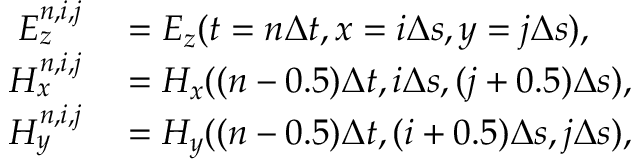Convert formula to latex. <formula><loc_0><loc_0><loc_500><loc_500>\begin{array} { r l } { E _ { z } ^ { n , i , j } } & = E _ { z } ( t = n \Delta t , x = i \Delta s , y = j \Delta s ) , } \\ { H _ { x } ^ { n , i , j } } & = H _ { x } ( ( n - 0 . 5 ) \Delta t , i \Delta s , ( j + 0 . 5 ) \Delta s ) , } \\ { H _ { y } ^ { n , i , j } } & = H _ { y } ( ( n - 0 . 5 ) \Delta t , ( i + 0 . 5 ) \Delta s , j \Delta s ) , } \end{array}</formula> 